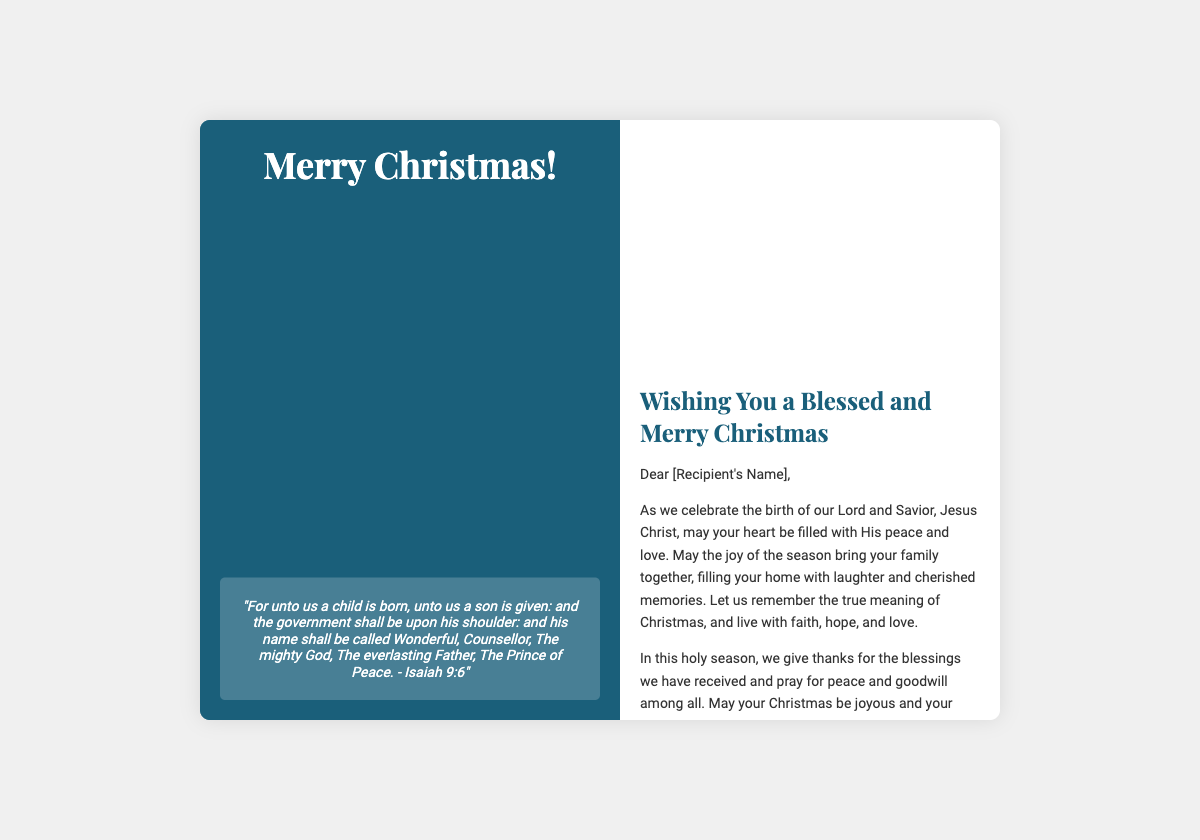What is the title on the front cover? The title on the front cover of the card is a greeting message expressing festive cheer.
Answer: Merry Christmas! What Biblical verse is included? The document contains a verse from the Bible related to the birth of Jesus Christ.
Answer: Isaiah 9:6 What is the primary color of the front cover? The front cover features a dominant color that sets an inviting and festive mood.
Answer: Dark blue What is the main theme of the inside message? The inside message focuses on the essence of the holiday spirit, emphasizing family and faith.
Answer: Faith and family What does the inside message wish for the recipient's New Year? The inside message includes a specific sentiment about the upcoming year.
Answer: God's grace What imagery is used on the inside left of the card? The document describes the type of imagery present on the left side of the card's interior.
Answer: Church and snow What kind of tone does the message convey? The tone of the message is reflective of a particular emotion or sentiment commonly found in holiday greetings.
Answer: Warm and heartfelt Who is the card addressed to in the greeting? The greeting includes a placeholder for the intended recipient's name.
Answer: [Recipient's Name] What does the greeting encourage the recipient to remember? The message emphasizes a specific aspect of the holiday celebration.
Answer: The true meaning of Christmas 